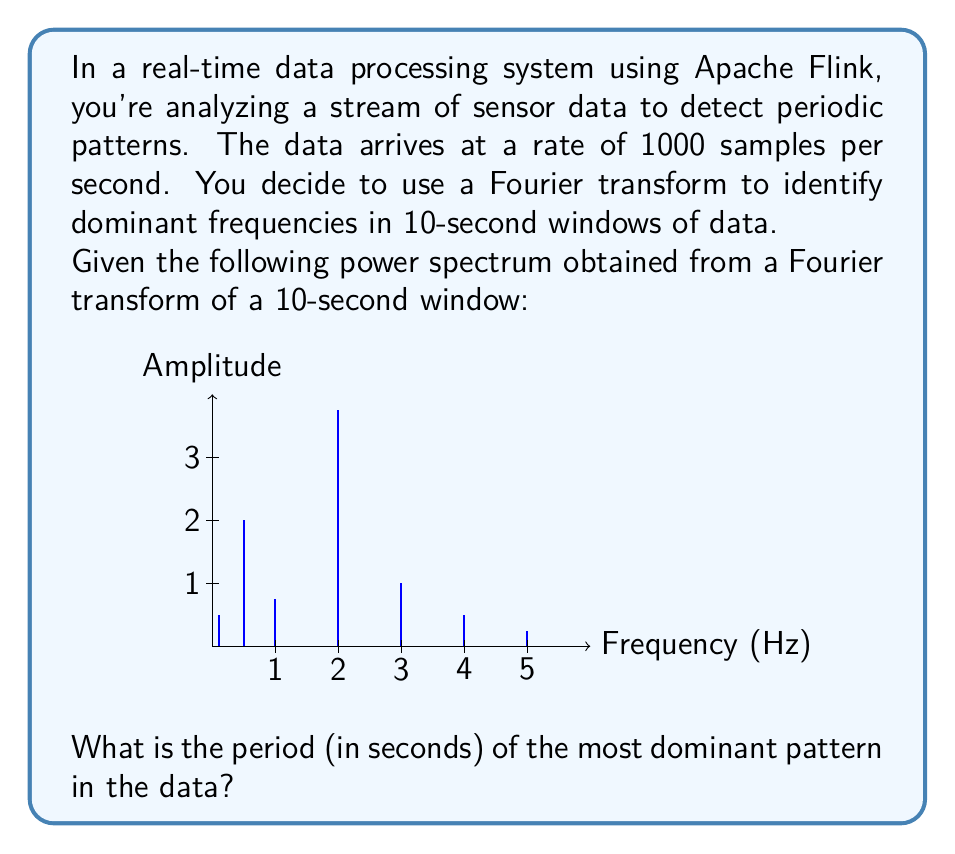Could you help me with this problem? To solve this problem, we need to follow these steps:

1) First, recall that the relationship between frequency ($f$) and period ($T$) is:

   $$T = \frac{1}{f}$$

2) From the power spectrum graph, we need to identify the frequency with the highest amplitude. This represents the most dominant pattern in the data.

3) Looking at the graph, we can see that the highest peak occurs at a frequency of 2.0 Hz.

4) Now, we can calculate the period by applying the formula from step 1:

   $$T = \frac{1}{f} = \frac{1}{2.0 \text{ Hz}} = 0.5 \text{ seconds}$$

5) Therefore, the most dominant pattern in the data repeats every 0.5 seconds.

It's worth noting that in a real Apache Flink application, you would typically implement this analysis using a windowing operation followed by a Fourier transform. The window size (10 seconds in this case) determines the frequency resolution of your analysis. Flink's ability to process streaming data in real-time makes it well-suited for this kind of continuous spectral analysis.
Answer: 0.5 seconds 